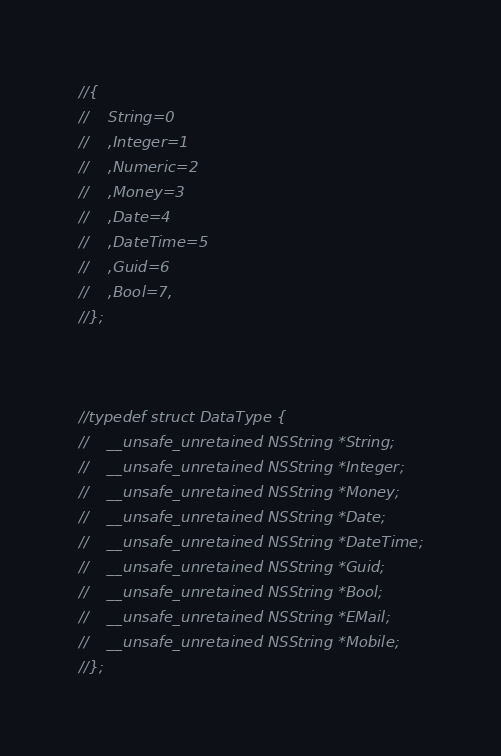<code> <loc_0><loc_0><loc_500><loc_500><_C_>//{
//    String=0
//    ,Integer=1
//    ,Numeric=2
//    ,Money=3
//    ,Date=4
//    ,DateTime=5
//    ,Guid=6
//    ,Bool=7,
//};



//typedef struct DataType {
//    __unsafe_unretained NSString *String;
//    __unsafe_unretained NSString *Integer;
//    __unsafe_unretained NSString *Money;
//    __unsafe_unretained NSString *Date;
//    __unsafe_unretained NSString *DateTime;
//    __unsafe_unretained NSString *Guid;
//    __unsafe_unretained NSString *Bool;
//    __unsafe_unretained NSString *EMail;
//    __unsafe_unretained NSString *Mobile;
//};
</code> 